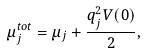Convert formula to latex. <formula><loc_0><loc_0><loc_500><loc_500>\mu _ { j } ^ { t o t } = \mu _ { j } + \frac { q _ { j } ^ { 2 } V ( 0 ) } { 2 } ,</formula> 